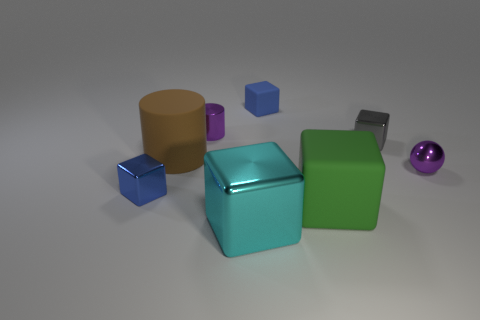Subtract 2 blocks. How many blocks are left? 3 Subtract all gray blocks. How many blocks are left? 4 Subtract all large cyan cubes. How many cubes are left? 4 Subtract all brown cubes. Subtract all blue cylinders. How many cubes are left? 5 Add 1 tiny brown objects. How many objects exist? 9 Subtract all balls. How many objects are left? 7 Subtract 0 red balls. How many objects are left? 8 Subtract all large brown rubber cylinders. Subtract all big green blocks. How many objects are left? 6 Add 6 purple balls. How many purple balls are left? 7 Add 4 small metallic balls. How many small metallic balls exist? 5 